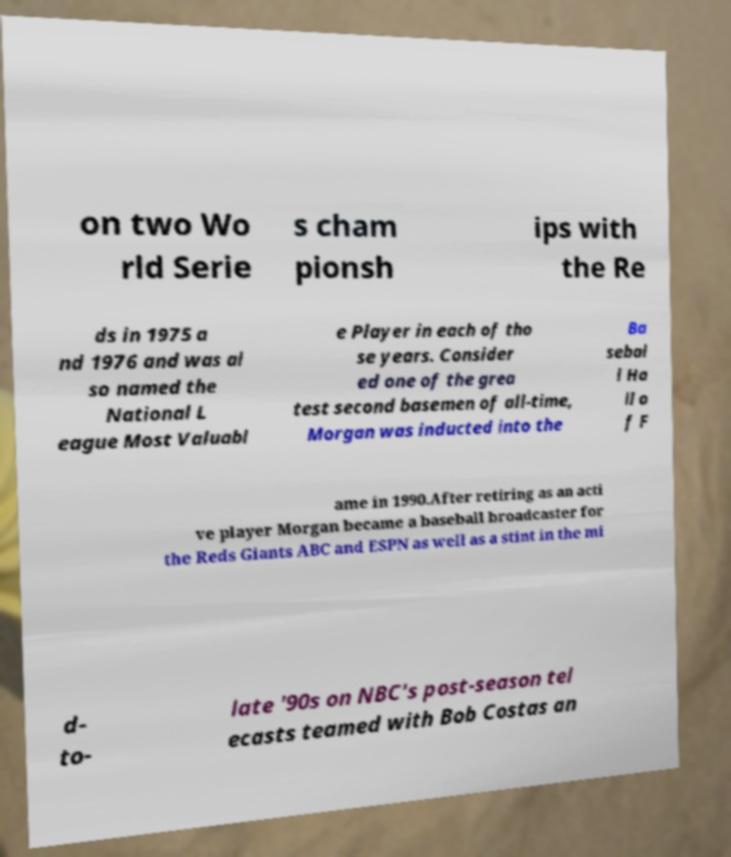Please identify and transcribe the text found in this image. on two Wo rld Serie s cham pionsh ips with the Re ds in 1975 a nd 1976 and was al so named the National L eague Most Valuabl e Player in each of tho se years. Consider ed one of the grea test second basemen of all-time, Morgan was inducted into the Ba sebal l Ha ll o f F ame in 1990.After retiring as an acti ve player Morgan became a baseball broadcaster for the Reds Giants ABC and ESPN as well as a stint in the mi d- to- late '90s on NBC's post-season tel ecasts teamed with Bob Costas an 